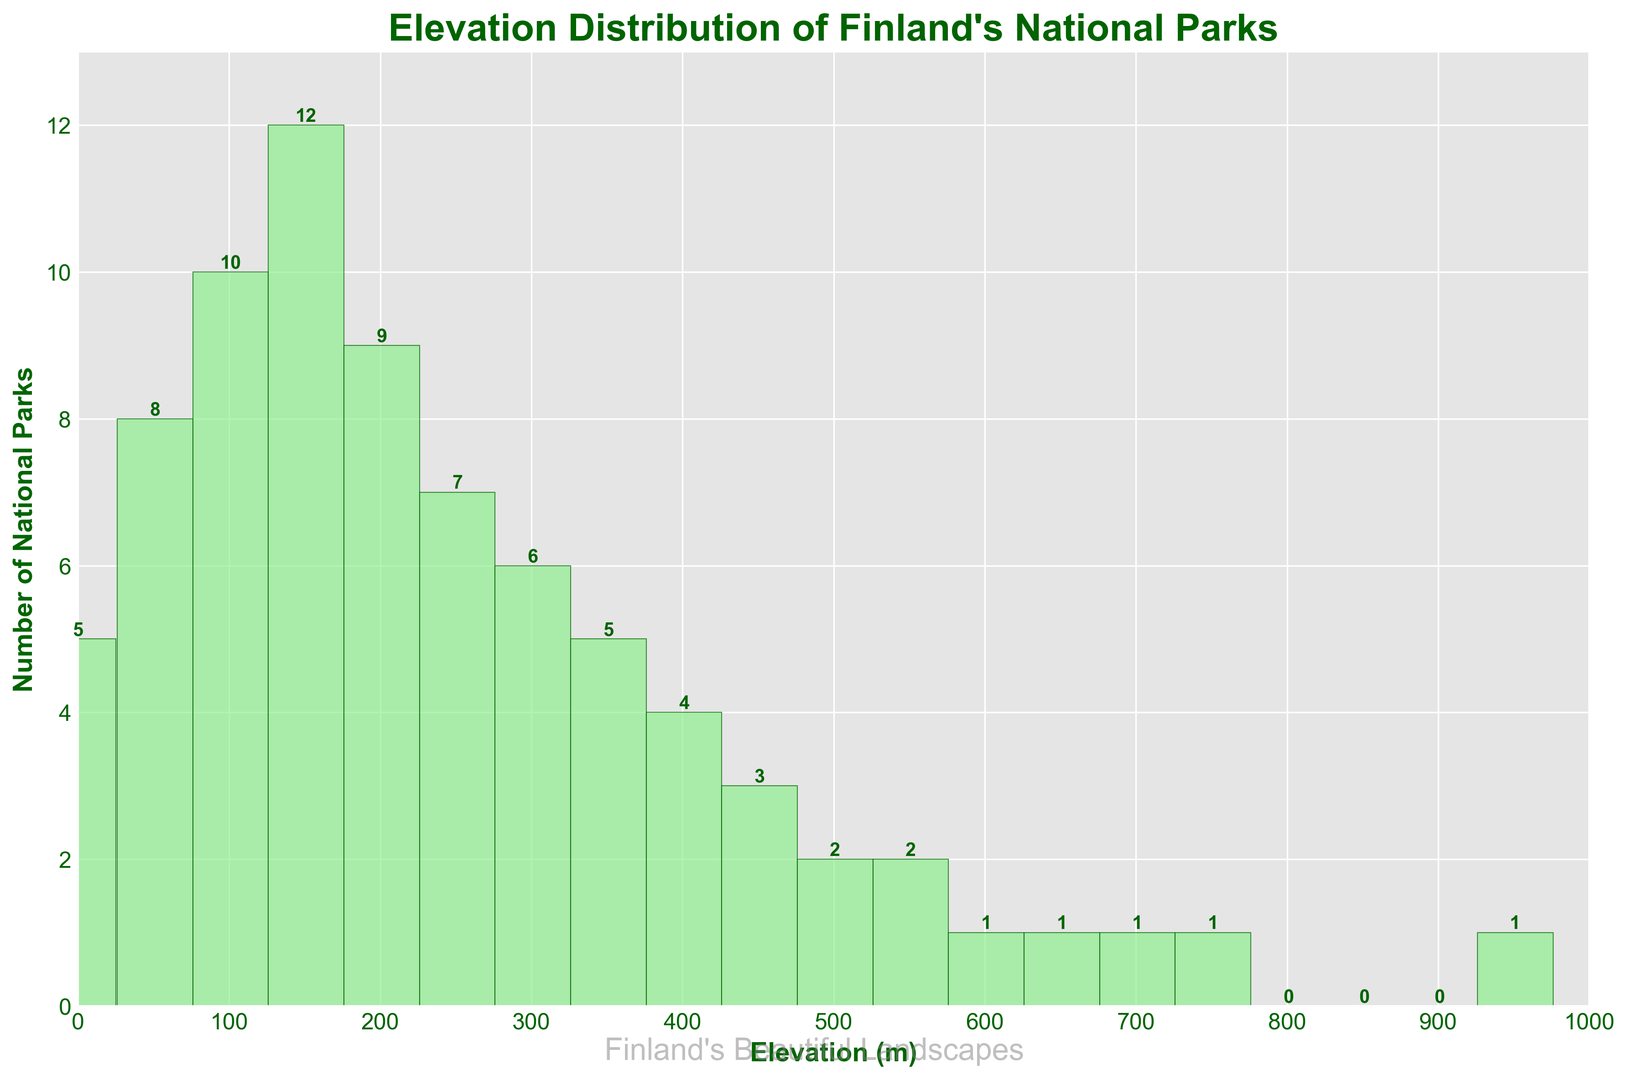what is the total number of national parks in the figure? To find the total number of national parks, sum the number of parks in each elevation range (5 + 8 + 10 + 12 + 9 + 7 + 6 + 5 + 4 + 3 + 2 + 2 + 1 + 1 + 1 + 1 + 0 + 0 + 0 + 1) = 77
Answer: 77 Which elevation range has the highest number of national parks? Look at the tallest bar in the histogram, which represents the elevation range with the highest count. Here, the bar for the 151-200m range is the tallest with a count of 12.
Answer: 151-200m How many national parks lie above 500 meters? Add the number of parks in elevation ranges above 500m: (2 + 2 + 1 + 1 + 1 + 1) = 8
Answer: 8 Which elevation range has an equal number of national parks compared to the 301-350m range? The 301-350m range has 6 parks. Looking at the bars, the range 351-400m also has 6 parks.
Answer: 351-400m What is the difference in the number of parks between the 101-150m and 251-300m ranges? Subtract the number of parks in the 251-300m range (7) from the number of parks in the 101-150m range (10). So, 10 - 7 = 3.
Answer: 3 Between which elevation ranges is the count of national parks decreasing continuously from 12 to 3? Observe the decreasing sequence in the heights of the bars from 151-200m to 451-500m. The counts are 12, 9, 7, 6, 5, 4, 3.
Answer: 151-200m to 451-500m What is the average number of national parks in the elevation ranges above 600 meters? Add the number of parks in each elevation range above 600m (1 + 1 + 1 + 1), then divide by the number of these ranges (4). So, (1 + 1 + 1 + 1) / 4 = 1
Answer: 1 Which elevation ranges have no national parks? Identify the ranges with zero values on the histogram. These ranges are 801-850m, 851-900m, and 901-1000m.
Answer: 801-850m, 851-900m, 901-1000m 